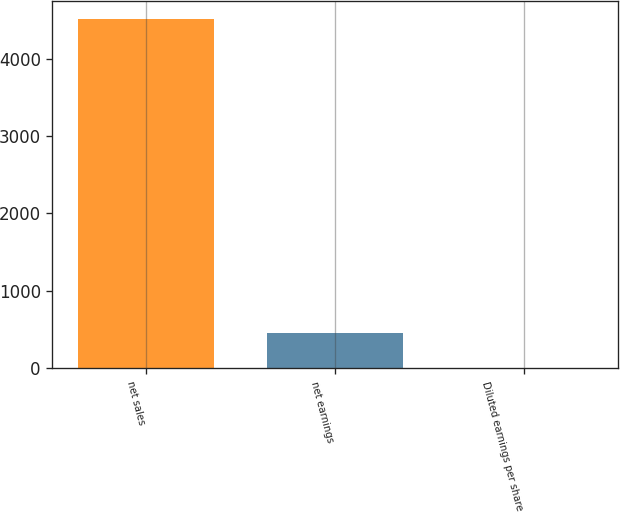Convert chart to OTSL. <chart><loc_0><loc_0><loc_500><loc_500><bar_chart><fcel>net sales<fcel>net earnings<fcel>Diluted earnings per share<nl><fcel>4517.3<fcel>455.34<fcel>4.01<nl></chart> 